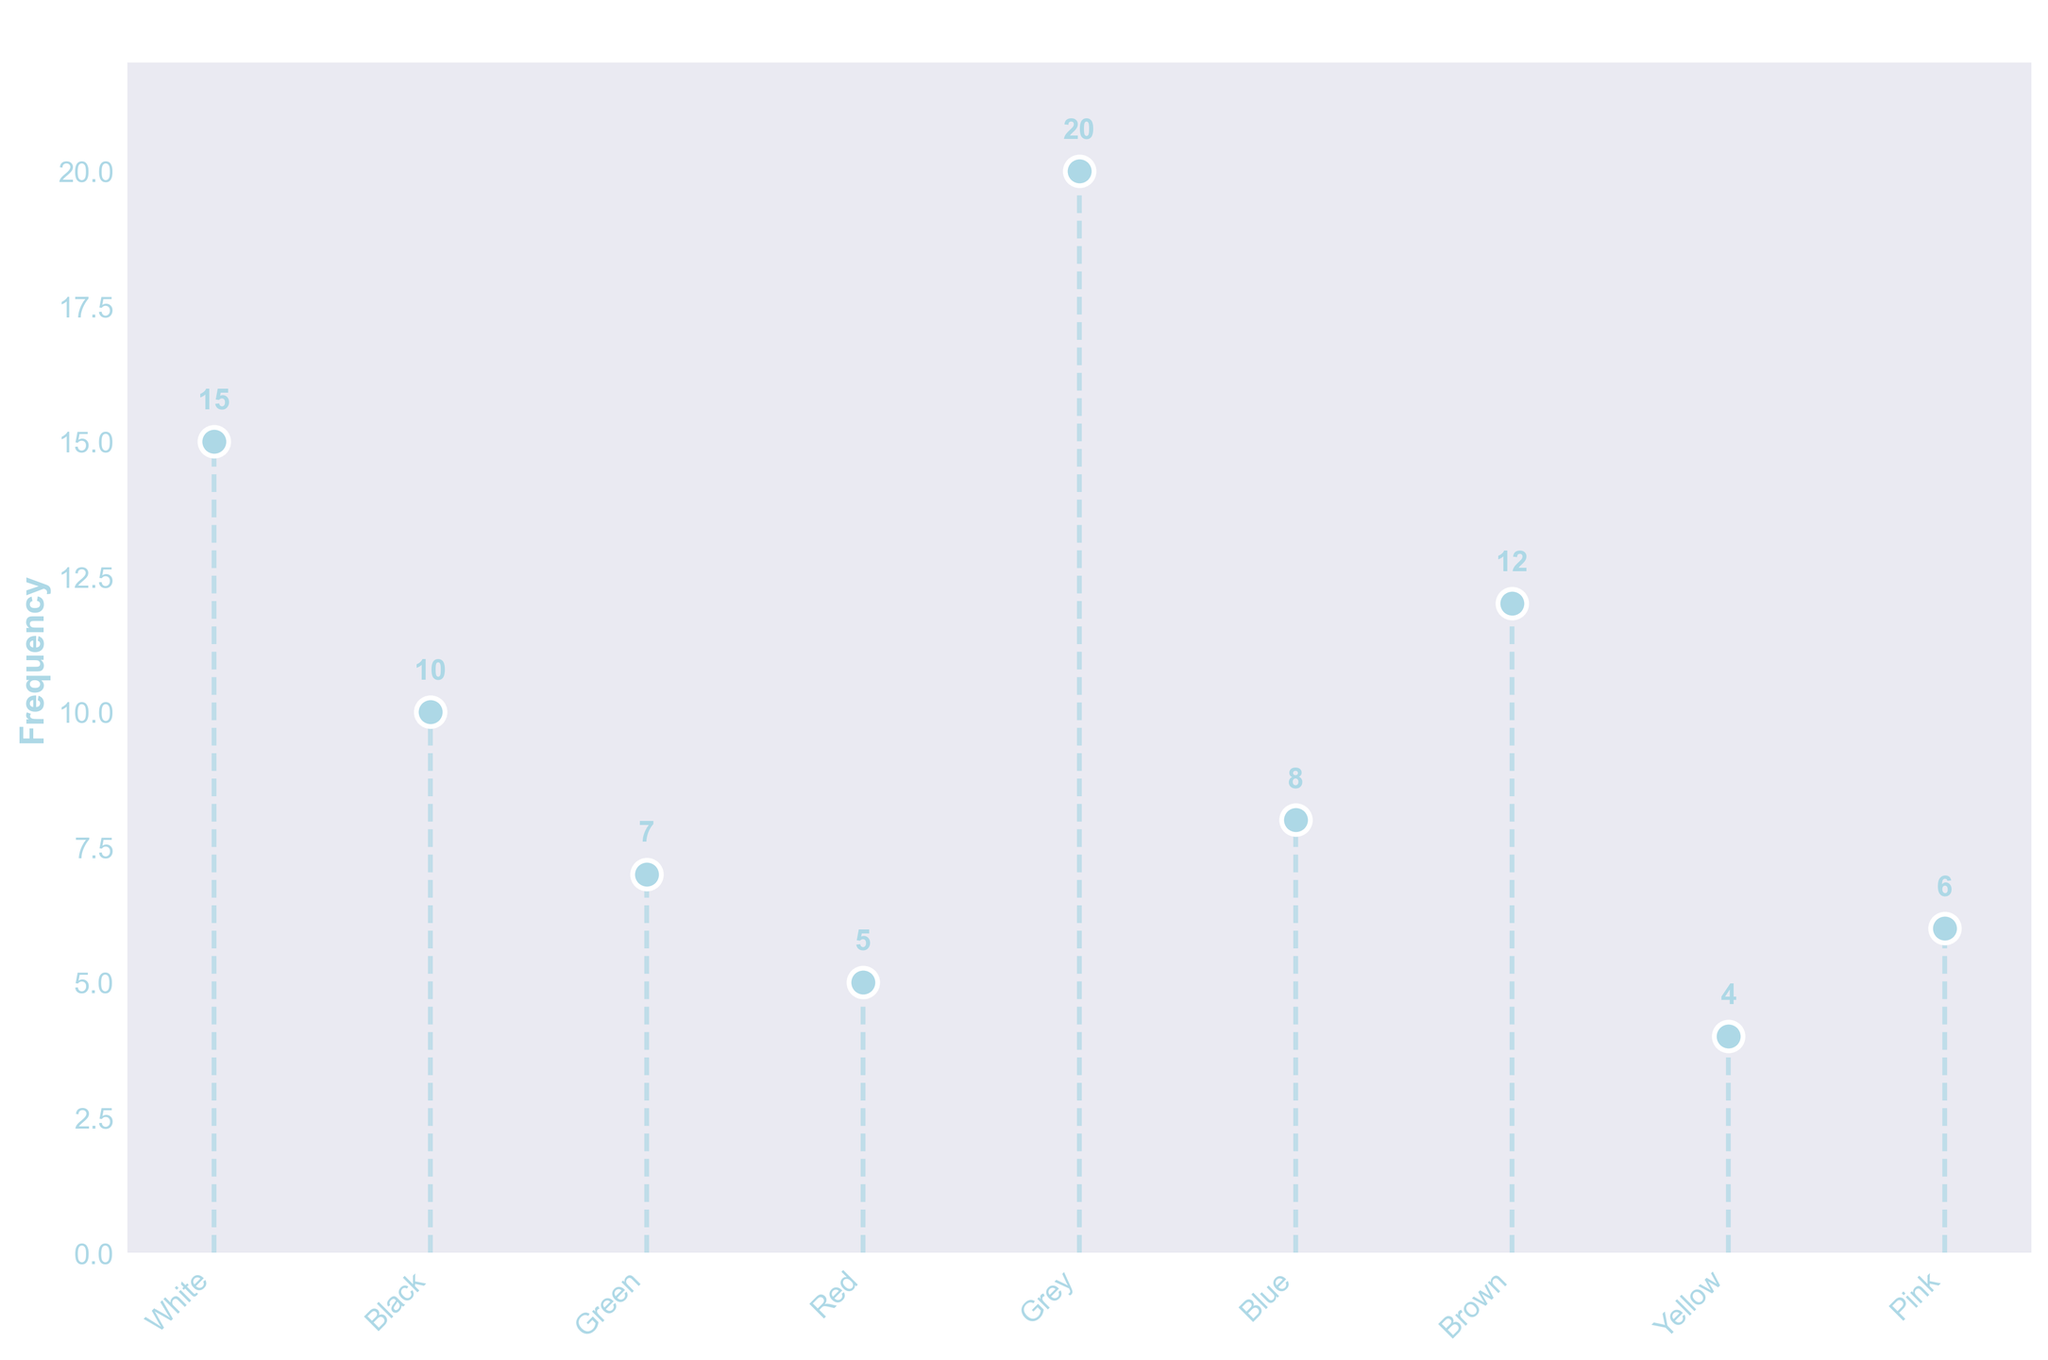What is the title of the figure? The title is usually located at the top of the figure, and it provides a brief description of what the figure is about. In this case, the title is clearly stated.
Answer: Frequency of Different Stone Colours in Quarry Sites Which stone colour has the highest frequency? By looking at the y-values and comparing the frequencies, it's evident that one stone colour has a notably higher frequency than the others.
Answer: Grey What's the total frequency of all stone colors combined? To find the total frequency, sum up the frequencies of all the stone colors: 15 (White) + 10 (Black) + 7 (Green) + 5 (Red) + 20 (Grey) + 8 (Blue) + 12 (Brown) + 4 (Yellow) + 6 (Pink) = 87
Answer: 87 How many stone colors have a frequency greater than 10? Identify the stone colors with frequencies more than 10 and count them. There are three frequencies fitting this criteria: 15 (White), 20 (Grey), 12 (Brown).
Answer: 3 Which two stone colors have the smallest frequencies? To find the smallest frequencies, look at the lowest y-values. The two smallest frequencies are 4 (Yellow) and 5 (Red).
Answer: Yellow and Red Which stone color has a frequency closest to 10? Identify the stone color whose frequency is closest to 10. By comparing the values, the frequencies close to 10 are 8 (Blue) and 12 (Brown), so Brown is the closest.
Answer: Brown If you combine the frequencies of Blue and Green stones, what is the total? Add the frequencies of Blue (8) and Green (7): 8 + 7 = 15.
Answer: 15 What is the difference in frequency between the most and least common stone colors? Subtract the smallest frequency (4 for Yellow) from the largest frequency (20 for Grey): 20 - 4 = 16
Answer: 16 What is the average frequency of the stone colors? Sum up the frequencies (87 from above) and divide by the number of stone colors (9): 87 / 9 = 9.67
Answer: 9.67 What pattern can be observed about the frequencies relative to stone color? Observe the distribution of frequencies across different stone colors. A pattern to remark is whether frequencies decrease, increase, or vary without a clear trend. In this case, there is no clear increasing or decreasing pattern; some colors are more frequent while others are less.
Answer: No clear pattern 